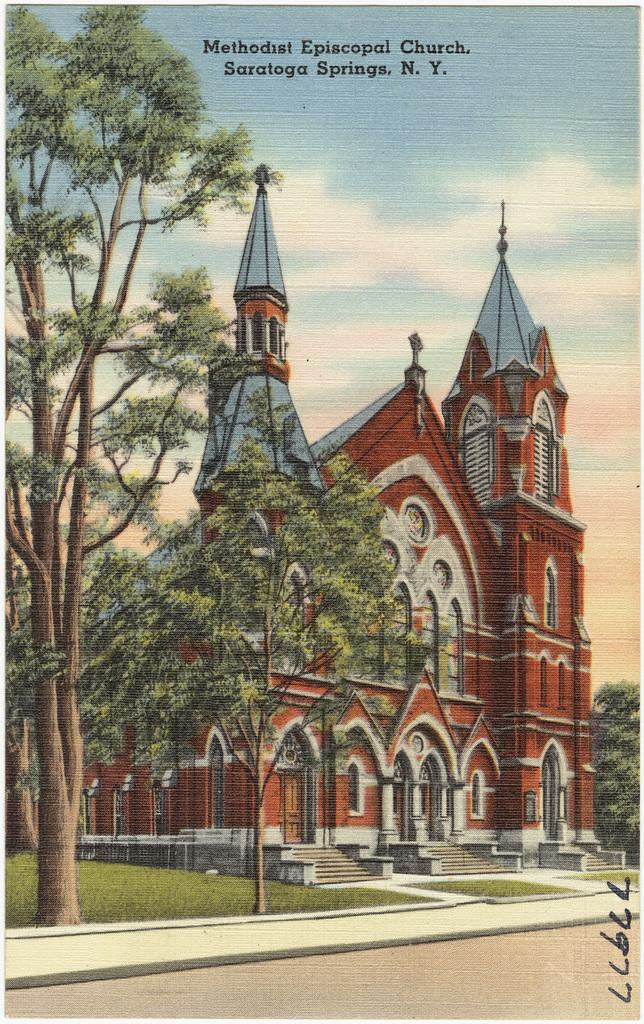What is the main structure in the center of the image? There is a castle in the center of the image. What type of vegetation can be seen in the image? There are trees in the image. What covers the ground in the image? There is grass on the ground in the image. How would you describe the sky in the image? The sky is cloudy in the image. What color of ink is being used to write on the castle in the image? There is no writing or ink present on the castle in the image. How does the guide help visitors navigate the castle in the image? There is no guide or indication of visitors in the image. 